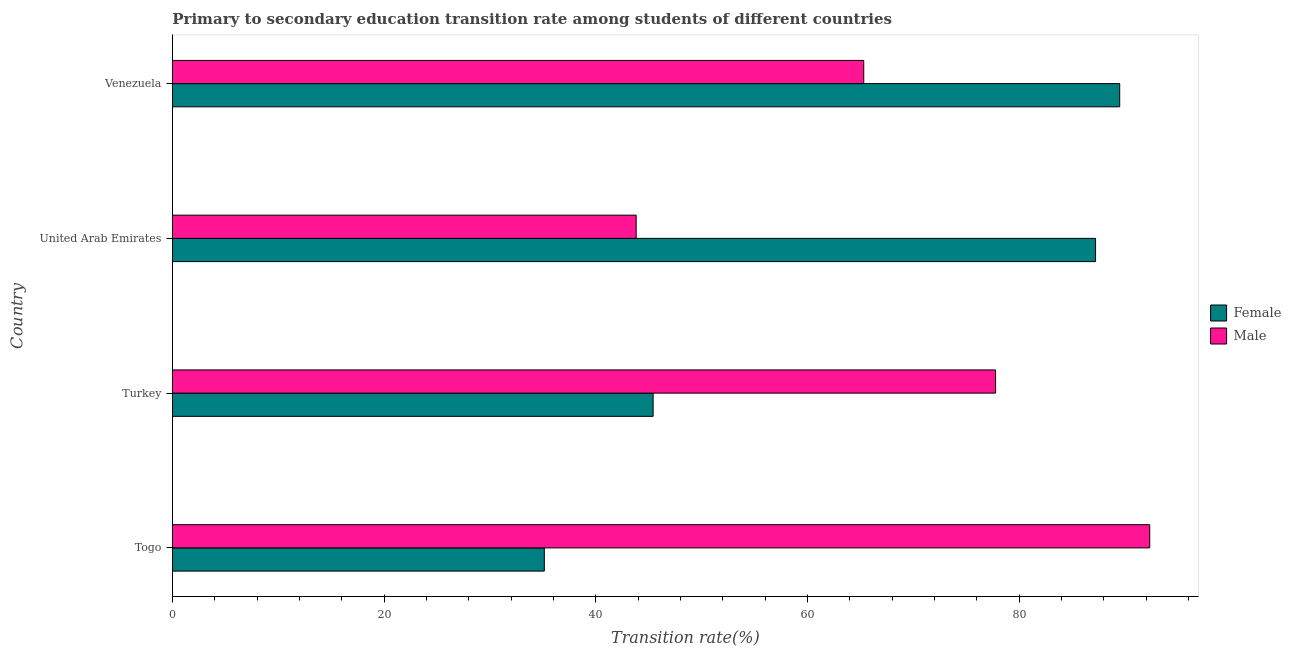How many different coloured bars are there?
Provide a succinct answer. 2. Are the number of bars per tick equal to the number of legend labels?
Offer a terse response. Yes. How many bars are there on the 1st tick from the top?
Keep it short and to the point. 2. What is the transition rate among male students in Togo?
Offer a terse response. 92.35. Across all countries, what is the maximum transition rate among female students?
Keep it short and to the point. 89.51. Across all countries, what is the minimum transition rate among female students?
Make the answer very short. 35.15. In which country was the transition rate among female students maximum?
Your response must be concise. Venezuela. In which country was the transition rate among male students minimum?
Ensure brevity in your answer.  United Arab Emirates. What is the total transition rate among female students in the graph?
Provide a short and direct response. 257.32. What is the difference between the transition rate among female students in Togo and that in Venezuela?
Your answer should be compact. -54.37. What is the difference between the transition rate among female students in Togo and the transition rate among male students in Turkey?
Provide a short and direct response. -42.64. What is the average transition rate among male students per country?
Offer a terse response. 69.82. What is the difference between the transition rate among female students and transition rate among male students in Togo?
Offer a terse response. -57.2. In how many countries, is the transition rate among male students greater than 80 %?
Ensure brevity in your answer.  1. What is the ratio of the transition rate among female students in Togo to that in Turkey?
Keep it short and to the point. 0.77. Is the difference between the transition rate among female students in United Arab Emirates and Venezuela greater than the difference between the transition rate among male students in United Arab Emirates and Venezuela?
Provide a short and direct response. Yes. What is the difference between the highest and the second highest transition rate among male students?
Provide a short and direct response. 14.56. What is the difference between the highest and the lowest transition rate among male students?
Your response must be concise. 48.52. In how many countries, is the transition rate among female students greater than the average transition rate among female students taken over all countries?
Keep it short and to the point. 2. Is the sum of the transition rate among male students in Turkey and Venezuela greater than the maximum transition rate among female students across all countries?
Your answer should be very brief. Yes. What does the 2nd bar from the top in United Arab Emirates represents?
Make the answer very short. Female. What does the 2nd bar from the bottom in Turkey represents?
Your answer should be very brief. Male. Are all the bars in the graph horizontal?
Your answer should be compact. Yes. How many countries are there in the graph?
Your response must be concise. 4. What is the difference between two consecutive major ticks on the X-axis?
Provide a short and direct response. 20. Where does the legend appear in the graph?
Keep it short and to the point. Center right. How are the legend labels stacked?
Provide a short and direct response. Vertical. What is the title of the graph?
Offer a very short reply. Primary to secondary education transition rate among students of different countries. Does "Time to export" appear as one of the legend labels in the graph?
Keep it short and to the point. No. What is the label or title of the X-axis?
Provide a short and direct response. Transition rate(%). What is the label or title of the Y-axis?
Make the answer very short. Country. What is the Transition rate(%) in Female in Togo?
Provide a short and direct response. 35.15. What is the Transition rate(%) in Male in Togo?
Offer a very short reply. 92.35. What is the Transition rate(%) of Female in Turkey?
Offer a very short reply. 45.43. What is the Transition rate(%) of Male in Turkey?
Your response must be concise. 77.78. What is the Transition rate(%) of Female in United Arab Emirates?
Make the answer very short. 87.23. What is the Transition rate(%) in Male in United Arab Emirates?
Your answer should be very brief. 43.82. What is the Transition rate(%) in Female in Venezuela?
Provide a succinct answer. 89.51. What is the Transition rate(%) in Male in Venezuela?
Give a very brief answer. 65.33. Across all countries, what is the maximum Transition rate(%) of Female?
Make the answer very short. 89.51. Across all countries, what is the maximum Transition rate(%) of Male?
Your response must be concise. 92.35. Across all countries, what is the minimum Transition rate(%) in Female?
Provide a short and direct response. 35.15. Across all countries, what is the minimum Transition rate(%) of Male?
Your answer should be very brief. 43.82. What is the total Transition rate(%) in Female in the graph?
Your response must be concise. 257.32. What is the total Transition rate(%) in Male in the graph?
Provide a succinct answer. 279.28. What is the difference between the Transition rate(%) of Female in Togo and that in Turkey?
Give a very brief answer. -10.28. What is the difference between the Transition rate(%) of Male in Togo and that in Turkey?
Give a very brief answer. 14.56. What is the difference between the Transition rate(%) in Female in Togo and that in United Arab Emirates?
Keep it short and to the point. -52.08. What is the difference between the Transition rate(%) of Male in Togo and that in United Arab Emirates?
Keep it short and to the point. 48.52. What is the difference between the Transition rate(%) of Female in Togo and that in Venezuela?
Offer a very short reply. -54.37. What is the difference between the Transition rate(%) of Male in Togo and that in Venezuela?
Give a very brief answer. 27.02. What is the difference between the Transition rate(%) in Female in Turkey and that in United Arab Emirates?
Give a very brief answer. -41.8. What is the difference between the Transition rate(%) in Male in Turkey and that in United Arab Emirates?
Offer a terse response. 33.96. What is the difference between the Transition rate(%) of Female in Turkey and that in Venezuela?
Provide a succinct answer. -44.09. What is the difference between the Transition rate(%) of Male in Turkey and that in Venezuela?
Keep it short and to the point. 12.46. What is the difference between the Transition rate(%) of Female in United Arab Emirates and that in Venezuela?
Offer a terse response. -2.28. What is the difference between the Transition rate(%) in Male in United Arab Emirates and that in Venezuela?
Make the answer very short. -21.5. What is the difference between the Transition rate(%) in Female in Togo and the Transition rate(%) in Male in Turkey?
Provide a succinct answer. -42.64. What is the difference between the Transition rate(%) in Female in Togo and the Transition rate(%) in Male in United Arab Emirates?
Your answer should be very brief. -8.68. What is the difference between the Transition rate(%) of Female in Togo and the Transition rate(%) of Male in Venezuela?
Provide a short and direct response. -30.18. What is the difference between the Transition rate(%) of Female in Turkey and the Transition rate(%) of Male in United Arab Emirates?
Provide a short and direct response. 1.6. What is the difference between the Transition rate(%) of Female in Turkey and the Transition rate(%) of Male in Venezuela?
Give a very brief answer. -19.9. What is the difference between the Transition rate(%) of Female in United Arab Emirates and the Transition rate(%) of Male in Venezuela?
Keep it short and to the point. 21.9. What is the average Transition rate(%) of Female per country?
Ensure brevity in your answer.  64.33. What is the average Transition rate(%) of Male per country?
Keep it short and to the point. 69.82. What is the difference between the Transition rate(%) of Female and Transition rate(%) of Male in Togo?
Your response must be concise. -57.2. What is the difference between the Transition rate(%) in Female and Transition rate(%) in Male in Turkey?
Provide a short and direct response. -32.36. What is the difference between the Transition rate(%) of Female and Transition rate(%) of Male in United Arab Emirates?
Give a very brief answer. 43.41. What is the difference between the Transition rate(%) in Female and Transition rate(%) in Male in Venezuela?
Offer a very short reply. 24.19. What is the ratio of the Transition rate(%) of Female in Togo to that in Turkey?
Ensure brevity in your answer.  0.77. What is the ratio of the Transition rate(%) in Male in Togo to that in Turkey?
Provide a short and direct response. 1.19. What is the ratio of the Transition rate(%) of Female in Togo to that in United Arab Emirates?
Provide a short and direct response. 0.4. What is the ratio of the Transition rate(%) of Male in Togo to that in United Arab Emirates?
Your answer should be compact. 2.11. What is the ratio of the Transition rate(%) of Female in Togo to that in Venezuela?
Give a very brief answer. 0.39. What is the ratio of the Transition rate(%) of Male in Togo to that in Venezuela?
Your response must be concise. 1.41. What is the ratio of the Transition rate(%) of Female in Turkey to that in United Arab Emirates?
Provide a short and direct response. 0.52. What is the ratio of the Transition rate(%) in Male in Turkey to that in United Arab Emirates?
Offer a terse response. 1.77. What is the ratio of the Transition rate(%) in Female in Turkey to that in Venezuela?
Your answer should be compact. 0.51. What is the ratio of the Transition rate(%) in Male in Turkey to that in Venezuela?
Your answer should be compact. 1.19. What is the ratio of the Transition rate(%) of Female in United Arab Emirates to that in Venezuela?
Keep it short and to the point. 0.97. What is the ratio of the Transition rate(%) of Male in United Arab Emirates to that in Venezuela?
Give a very brief answer. 0.67. What is the difference between the highest and the second highest Transition rate(%) in Female?
Offer a terse response. 2.28. What is the difference between the highest and the second highest Transition rate(%) of Male?
Make the answer very short. 14.56. What is the difference between the highest and the lowest Transition rate(%) in Female?
Ensure brevity in your answer.  54.37. What is the difference between the highest and the lowest Transition rate(%) of Male?
Offer a terse response. 48.52. 